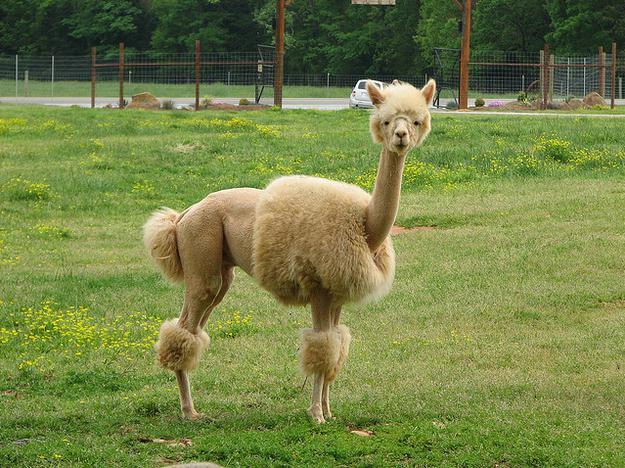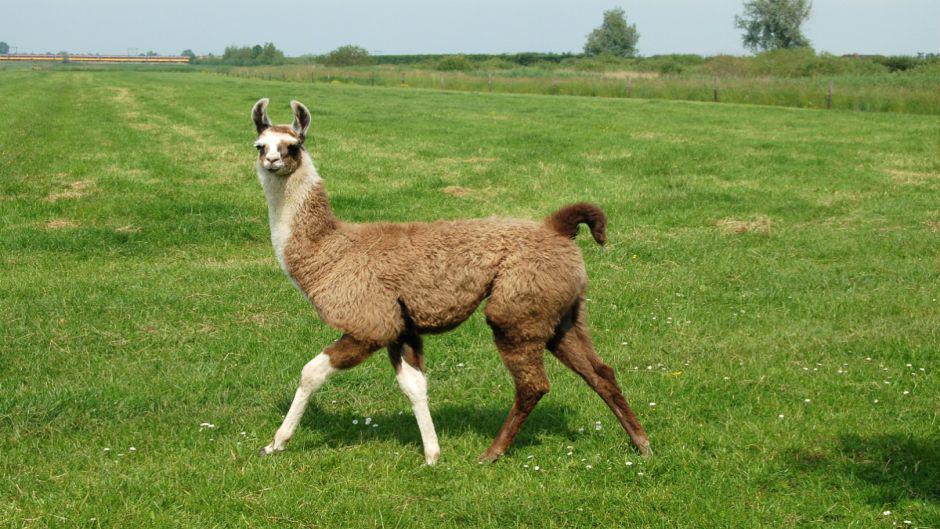The first image is the image on the left, the second image is the image on the right. For the images shown, is this caption "A juvenile llama can be seen near an adult llama." true? Answer yes or no. No. 